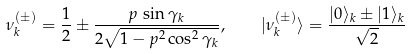<formula> <loc_0><loc_0><loc_500><loc_500>\nu _ { k } ^ { ( \pm ) } = \frac { 1 } { 2 } \pm \frac { p \, \sin \gamma _ { k } } { 2 \sqrt { 1 - p ^ { 2 } \cos ^ { 2 } \gamma _ { k } } } , \quad | \nu _ { k } ^ { ( \pm ) } \rangle = \frac { | 0 \rangle _ { k } \pm | 1 \rangle _ { k } } { \sqrt { 2 } }</formula> 